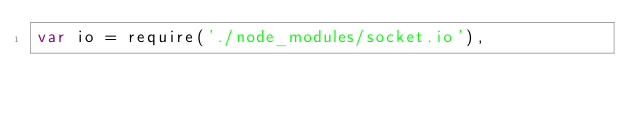<code> <loc_0><loc_0><loc_500><loc_500><_JavaScript_>var io = require('./node_modules/socket.io'),</code> 